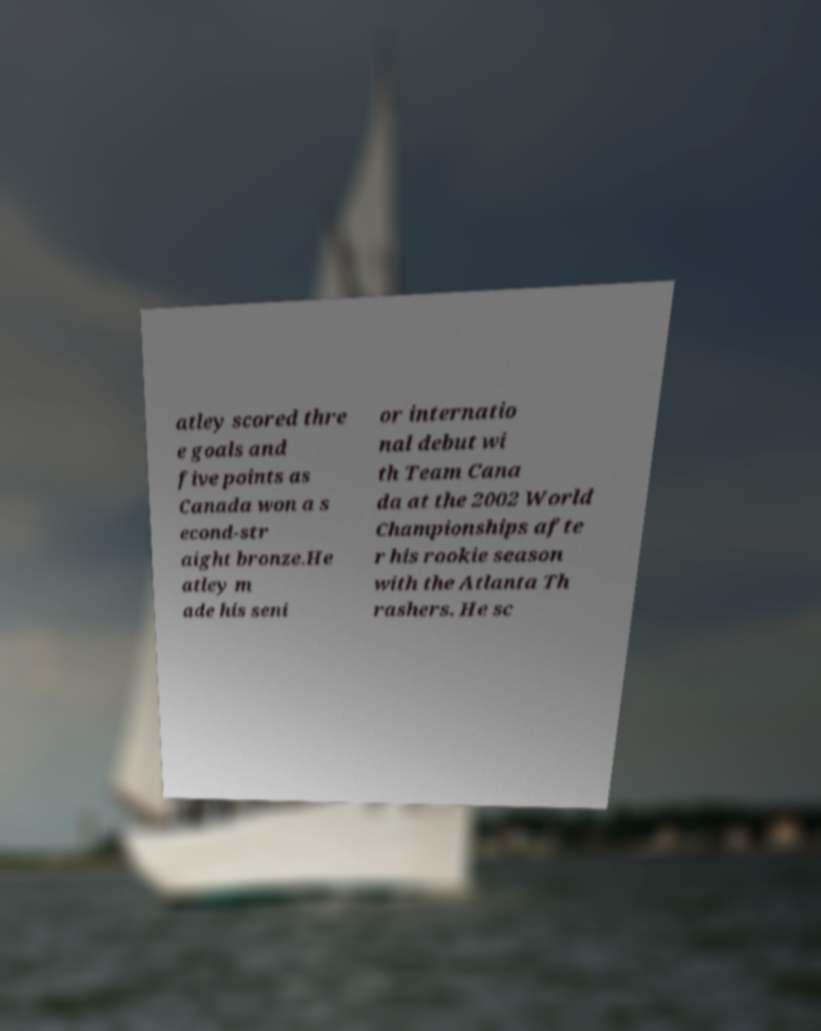Could you extract and type out the text from this image? atley scored thre e goals and five points as Canada won a s econd-str aight bronze.He atley m ade his seni or internatio nal debut wi th Team Cana da at the 2002 World Championships afte r his rookie season with the Atlanta Th rashers. He sc 